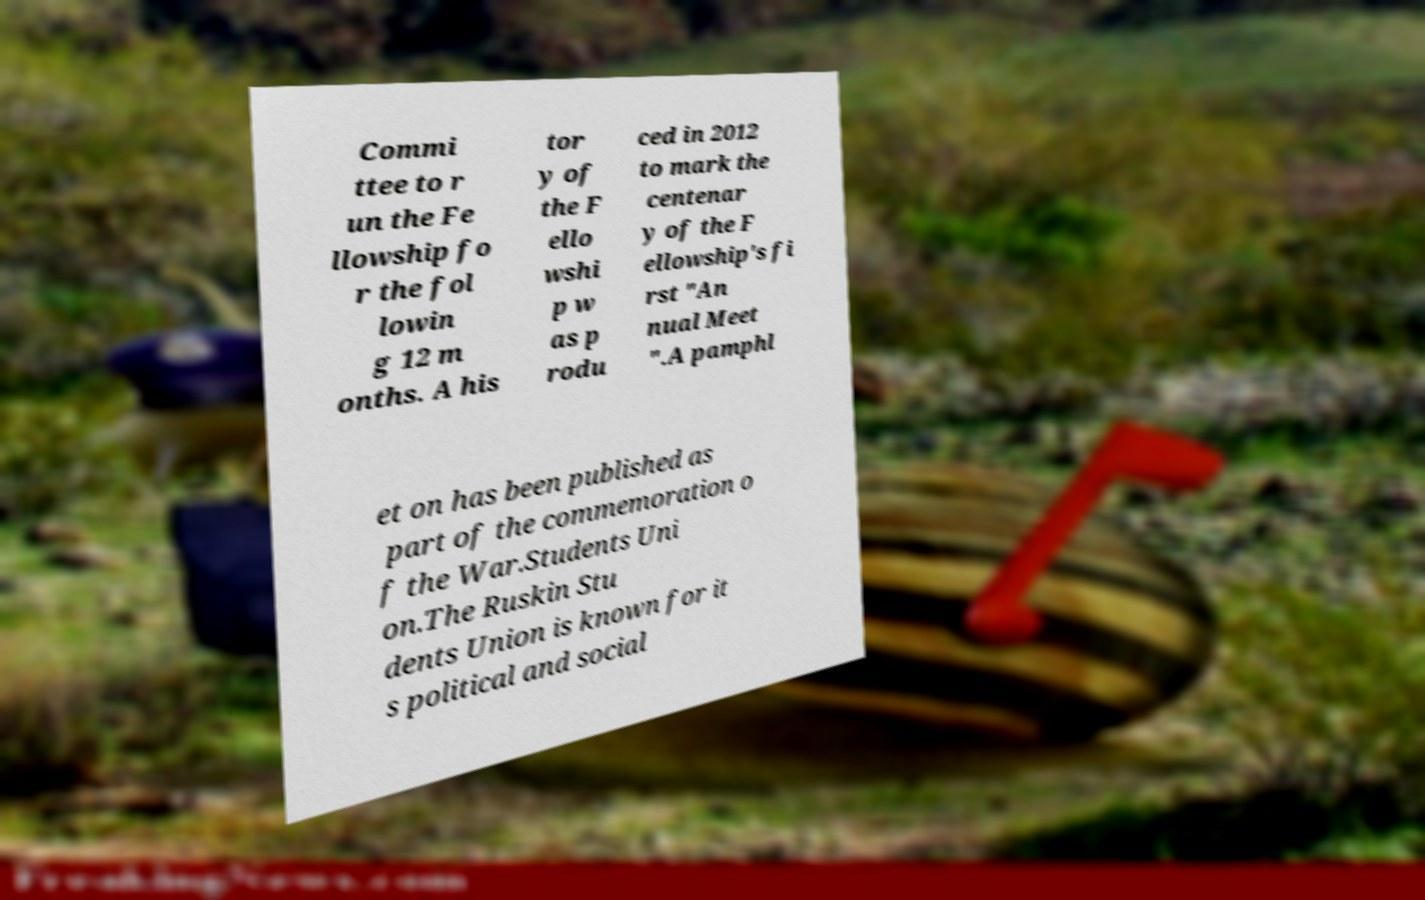I need the written content from this picture converted into text. Can you do that? Commi ttee to r un the Fe llowship fo r the fol lowin g 12 m onths. A his tor y of the F ello wshi p w as p rodu ced in 2012 to mark the centenar y of the F ellowship's fi rst "An nual Meet ".A pamphl et on has been published as part of the commemoration o f the War.Students Uni on.The Ruskin Stu dents Union is known for it s political and social 